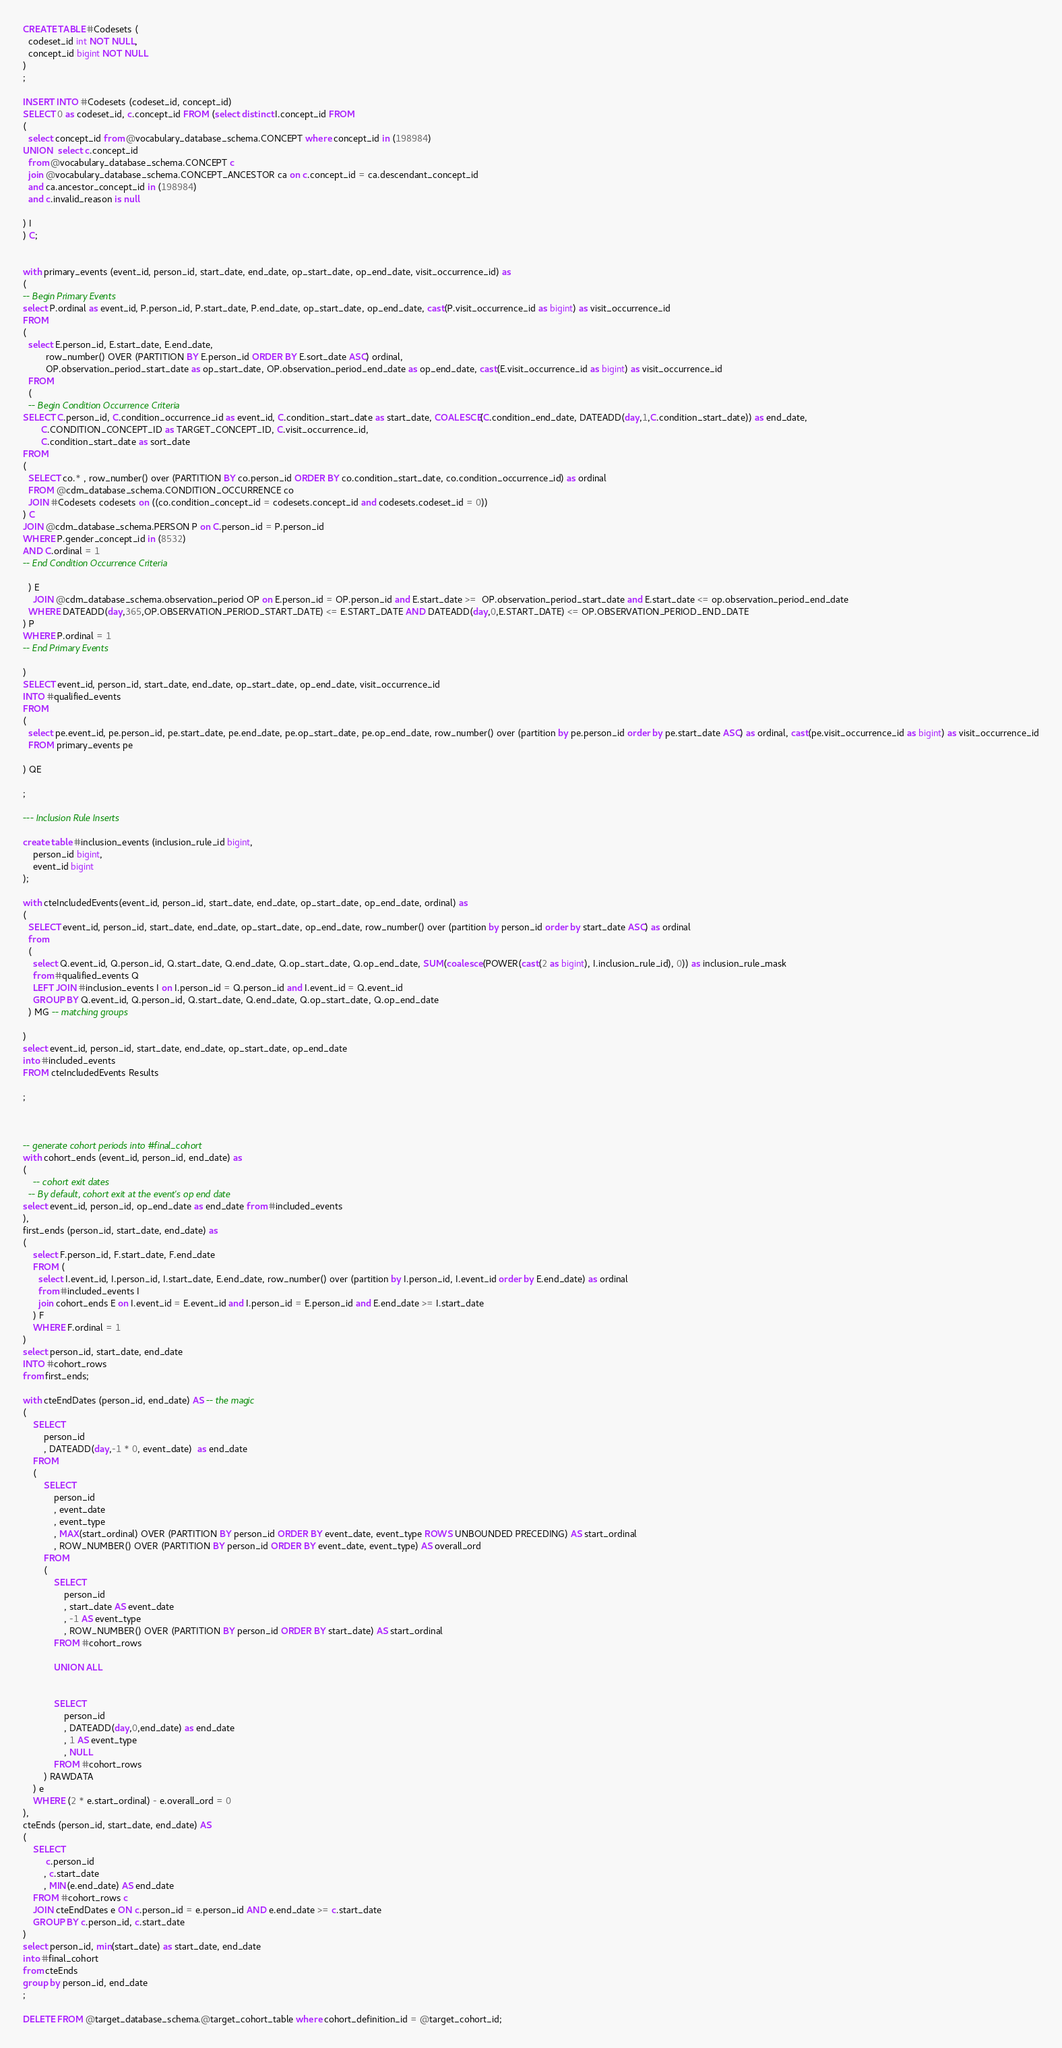<code> <loc_0><loc_0><loc_500><loc_500><_SQL_>CREATE TABLE #Codesets (
  codeset_id int NOT NULL,
  concept_id bigint NOT NULL
)
;

INSERT INTO #Codesets (codeset_id, concept_id)
SELECT 0 as codeset_id, c.concept_id FROM (select distinct I.concept_id FROM
(
  select concept_id from @vocabulary_database_schema.CONCEPT where concept_id in (198984)
UNION  select c.concept_id
  from @vocabulary_database_schema.CONCEPT c
  join @vocabulary_database_schema.CONCEPT_ANCESTOR ca on c.concept_id = ca.descendant_concept_id
  and ca.ancestor_concept_id in (198984)
  and c.invalid_reason is null

) I
) C;


with primary_events (event_id, person_id, start_date, end_date, op_start_date, op_end_date, visit_occurrence_id) as
(
-- Begin Primary Events
select P.ordinal as event_id, P.person_id, P.start_date, P.end_date, op_start_date, op_end_date, cast(P.visit_occurrence_id as bigint) as visit_occurrence_id
FROM
(
  select E.person_id, E.start_date, E.end_date,
         row_number() OVER (PARTITION BY E.person_id ORDER BY E.sort_date ASC) ordinal,
         OP.observation_period_start_date as op_start_date, OP.observation_period_end_date as op_end_date, cast(E.visit_occurrence_id as bigint) as visit_occurrence_id
  FROM
  (
  -- Begin Condition Occurrence Criteria
SELECT C.person_id, C.condition_occurrence_id as event_id, C.condition_start_date as start_date, COALESCE(C.condition_end_date, DATEADD(day,1,C.condition_start_date)) as end_date,
       C.CONDITION_CONCEPT_ID as TARGET_CONCEPT_ID, C.visit_occurrence_id,
       C.condition_start_date as sort_date
FROM
(
  SELECT co.* , row_number() over (PARTITION BY co.person_id ORDER BY co.condition_start_date, co.condition_occurrence_id) as ordinal
  FROM @cdm_database_schema.CONDITION_OCCURRENCE co
  JOIN #Codesets codesets on ((co.condition_concept_id = codesets.concept_id and codesets.codeset_id = 0))
) C
JOIN @cdm_database_schema.PERSON P on C.person_id = P.person_id
WHERE P.gender_concept_id in (8532)
AND C.ordinal = 1
-- End Condition Occurrence Criteria

  ) E
	JOIN @cdm_database_schema.observation_period OP on E.person_id = OP.person_id and E.start_date >=  OP.observation_period_start_date and E.start_date <= op.observation_period_end_date
  WHERE DATEADD(day,365,OP.OBSERVATION_PERIOD_START_DATE) <= E.START_DATE AND DATEADD(day,0,E.START_DATE) <= OP.OBSERVATION_PERIOD_END_DATE
) P
WHERE P.ordinal = 1
-- End Primary Events

)
SELECT event_id, person_id, start_date, end_date, op_start_date, op_end_date, visit_occurrence_id
INTO #qualified_events
FROM
(
  select pe.event_id, pe.person_id, pe.start_date, pe.end_date, pe.op_start_date, pe.op_end_date, row_number() over (partition by pe.person_id order by pe.start_date ASC) as ordinal, cast(pe.visit_occurrence_id as bigint) as visit_occurrence_id
  FROM primary_events pe

) QE

;

--- Inclusion Rule Inserts

create table #inclusion_events (inclusion_rule_id bigint,
	person_id bigint,
	event_id bigint
);

with cteIncludedEvents(event_id, person_id, start_date, end_date, op_start_date, op_end_date, ordinal) as
(
  SELECT event_id, person_id, start_date, end_date, op_start_date, op_end_date, row_number() over (partition by person_id order by start_date ASC) as ordinal
  from
  (
    select Q.event_id, Q.person_id, Q.start_date, Q.end_date, Q.op_start_date, Q.op_end_date, SUM(coalesce(POWER(cast(2 as bigint), I.inclusion_rule_id), 0)) as inclusion_rule_mask
    from #qualified_events Q
    LEFT JOIN #inclusion_events I on I.person_id = Q.person_id and I.event_id = Q.event_id
    GROUP BY Q.event_id, Q.person_id, Q.start_date, Q.end_date, Q.op_start_date, Q.op_end_date
  ) MG -- matching groups

)
select event_id, person_id, start_date, end_date, op_start_date, op_end_date
into #included_events
FROM cteIncludedEvents Results

;



-- generate cohort periods into #final_cohort
with cohort_ends (event_id, person_id, end_date) as
(
	-- cohort exit dates
  -- By default, cohort exit at the event's op end date
select event_id, person_id, op_end_date as end_date from #included_events
),
first_ends (person_id, start_date, end_date) as
(
	select F.person_id, F.start_date, F.end_date
	FROM (
	  select I.event_id, I.person_id, I.start_date, E.end_date, row_number() over (partition by I.person_id, I.event_id order by E.end_date) as ordinal
	  from #included_events I
	  join cohort_ends E on I.event_id = E.event_id and I.person_id = E.person_id and E.end_date >= I.start_date
	) F
	WHERE F.ordinal = 1
)
select person_id, start_date, end_date
INTO #cohort_rows
from first_ends;

with cteEndDates (person_id, end_date) AS -- the magic
(
	SELECT
		person_id
		, DATEADD(day,-1 * 0, event_date)  as end_date
	FROM
	(
		SELECT
			person_id
			, event_date
			, event_type
			, MAX(start_ordinal) OVER (PARTITION BY person_id ORDER BY event_date, event_type ROWS UNBOUNDED PRECEDING) AS start_ordinal
			, ROW_NUMBER() OVER (PARTITION BY person_id ORDER BY event_date, event_type) AS overall_ord
		FROM
		(
			SELECT
				person_id
				, start_date AS event_date
				, -1 AS event_type
				, ROW_NUMBER() OVER (PARTITION BY person_id ORDER BY start_date) AS start_ordinal
			FROM #cohort_rows

			UNION ALL


			SELECT
				person_id
				, DATEADD(day,0,end_date) as end_date
				, 1 AS event_type
				, NULL
			FROM #cohort_rows
		) RAWDATA
	) e
	WHERE (2 * e.start_ordinal) - e.overall_ord = 0
),
cteEnds (person_id, start_date, end_date) AS
(
	SELECT
		 c.person_id
		, c.start_date
		, MIN(e.end_date) AS end_date
	FROM #cohort_rows c
	JOIN cteEndDates e ON c.person_id = e.person_id AND e.end_date >= c.start_date
	GROUP BY c.person_id, c.start_date
)
select person_id, min(start_date) as start_date, end_date
into #final_cohort
from cteEnds
group by person_id, end_date
;

DELETE FROM @target_database_schema.@target_cohort_table where cohort_definition_id = @target_cohort_id;</code> 